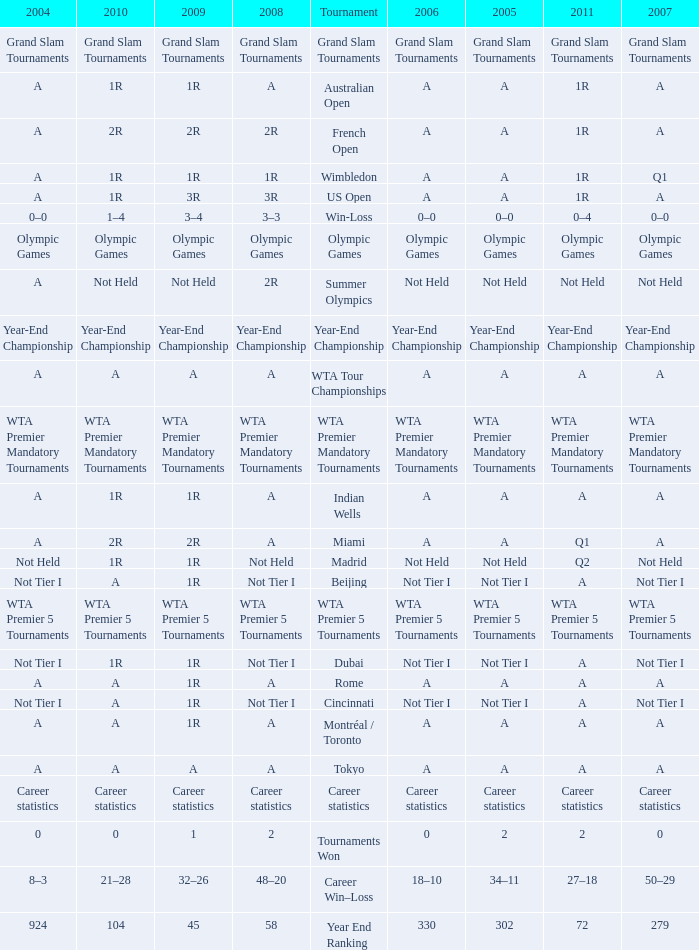What is 2004, when 2008 is "WTA Premier 5 Tournaments"? WTA Premier 5 Tournaments. Could you help me parse every detail presented in this table? {'header': ['2004', '2010', '2009', '2008', 'Tournament', '2006', '2005', '2011', '2007'], 'rows': [['Grand Slam Tournaments', 'Grand Slam Tournaments', 'Grand Slam Tournaments', 'Grand Slam Tournaments', 'Grand Slam Tournaments', 'Grand Slam Tournaments', 'Grand Slam Tournaments', 'Grand Slam Tournaments', 'Grand Slam Tournaments'], ['A', '1R', '1R', 'A', 'Australian Open', 'A', 'A', '1R', 'A'], ['A', '2R', '2R', '2R', 'French Open', 'A', 'A', '1R', 'A'], ['A', '1R', '1R', '1R', 'Wimbledon', 'A', 'A', '1R', 'Q1'], ['A', '1R', '3R', '3R', 'US Open', 'A', 'A', '1R', 'A'], ['0–0', '1–4', '3–4', '3–3', 'Win-Loss', '0–0', '0–0', '0–4', '0–0'], ['Olympic Games', 'Olympic Games', 'Olympic Games', 'Olympic Games', 'Olympic Games', 'Olympic Games', 'Olympic Games', 'Olympic Games', 'Olympic Games'], ['A', 'Not Held', 'Not Held', '2R', 'Summer Olympics', 'Not Held', 'Not Held', 'Not Held', 'Not Held'], ['Year-End Championship', 'Year-End Championship', 'Year-End Championship', 'Year-End Championship', 'Year-End Championship', 'Year-End Championship', 'Year-End Championship', 'Year-End Championship', 'Year-End Championship'], ['A', 'A', 'A', 'A', 'WTA Tour Championships', 'A', 'A', 'A', 'A'], ['WTA Premier Mandatory Tournaments', 'WTA Premier Mandatory Tournaments', 'WTA Premier Mandatory Tournaments', 'WTA Premier Mandatory Tournaments', 'WTA Premier Mandatory Tournaments', 'WTA Premier Mandatory Tournaments', 'WTA Premier Mandatory Tournaments', 'WTA Premier Mandatory Tournaments', 'WTA Premier Mandatory Tournaments'], ['A', '1R', '1R', 'A', 'Indian Wells', 'A', 'A', 'A', 'A'], ['A', '2R', '2R', 'A', 'Miami', 'A', 'A', 'Q1', 'A'], ['Not Held', '1R', '1R', 'Not Held', 'Madrid', 'Not Held', 'Not Held', 'Q2', 'Not Held'], ['Not Tier I', 'A', '1R', 'Not Tier I', 'Beijing', 'Not Tier I', 'Not Tier I', 'A', 'Not Tier I'], ['WTA Premier 5 Tournaments', 'WTA Premier 5 Tournaments', 'WTA Premier 5 Tournaments', 'WTA Premier 5 Tournaments', 'WTA Premier 5 Tournaments', 'WTA Premier 5 Tournaments', 'WTA Premier 5 Tournaments', 'WTA Premier 5 Tournaments', 'WTA Premier 5 Tournaments'], ['Not Tier I', '1R', '1R', 'Not Tier I', 'Dubai', 'Not Tier I', 'Not Tier I', 'A', 'Not Tier I'], ['A', 'A', '1R', 'A', 'Rome', 'A', 'A', 'A', 'A'], ['Not Tier I', 'A', '1R', 'Not Tier I', 'Cincinnati', 'Not Tier I', 'Not Tier I', 'A', 'Not Tier I'], ['A', 'A', '1R', 'A', 'Montréal / Toronto', 'A', 'A', 'A', 'A'], ['A', 'A', 'A', 'A', 'Tokyo', 'A', 'A', 'A', 'A'], ['Career statistics', 'Career statistics', 'Career statistics', 'Career statistics', 'Career statistics', 'Career statistics', 'Career statistics', 'Career statistics', 'Career statistics'], ['0', '0', '1', '2', 'Tournaments Won', '0', '2', '2', '0'], ['8–3', '21–28', '32–26', '48–20', 'Career Win–Loss', '18–10', '34–11', '27–18', '50–29'], ['924', '104', '45', '58', 'Year End Ranking', '330', '302', '72', '279']]} 